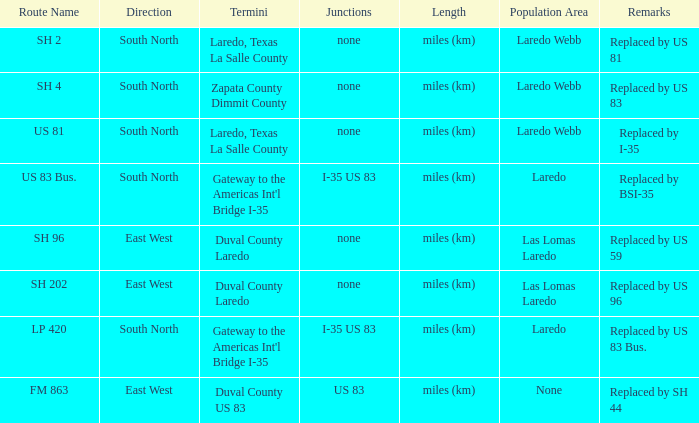How many junctions have "replaced by bsi-35" listed in their remarks section? 1.0. 